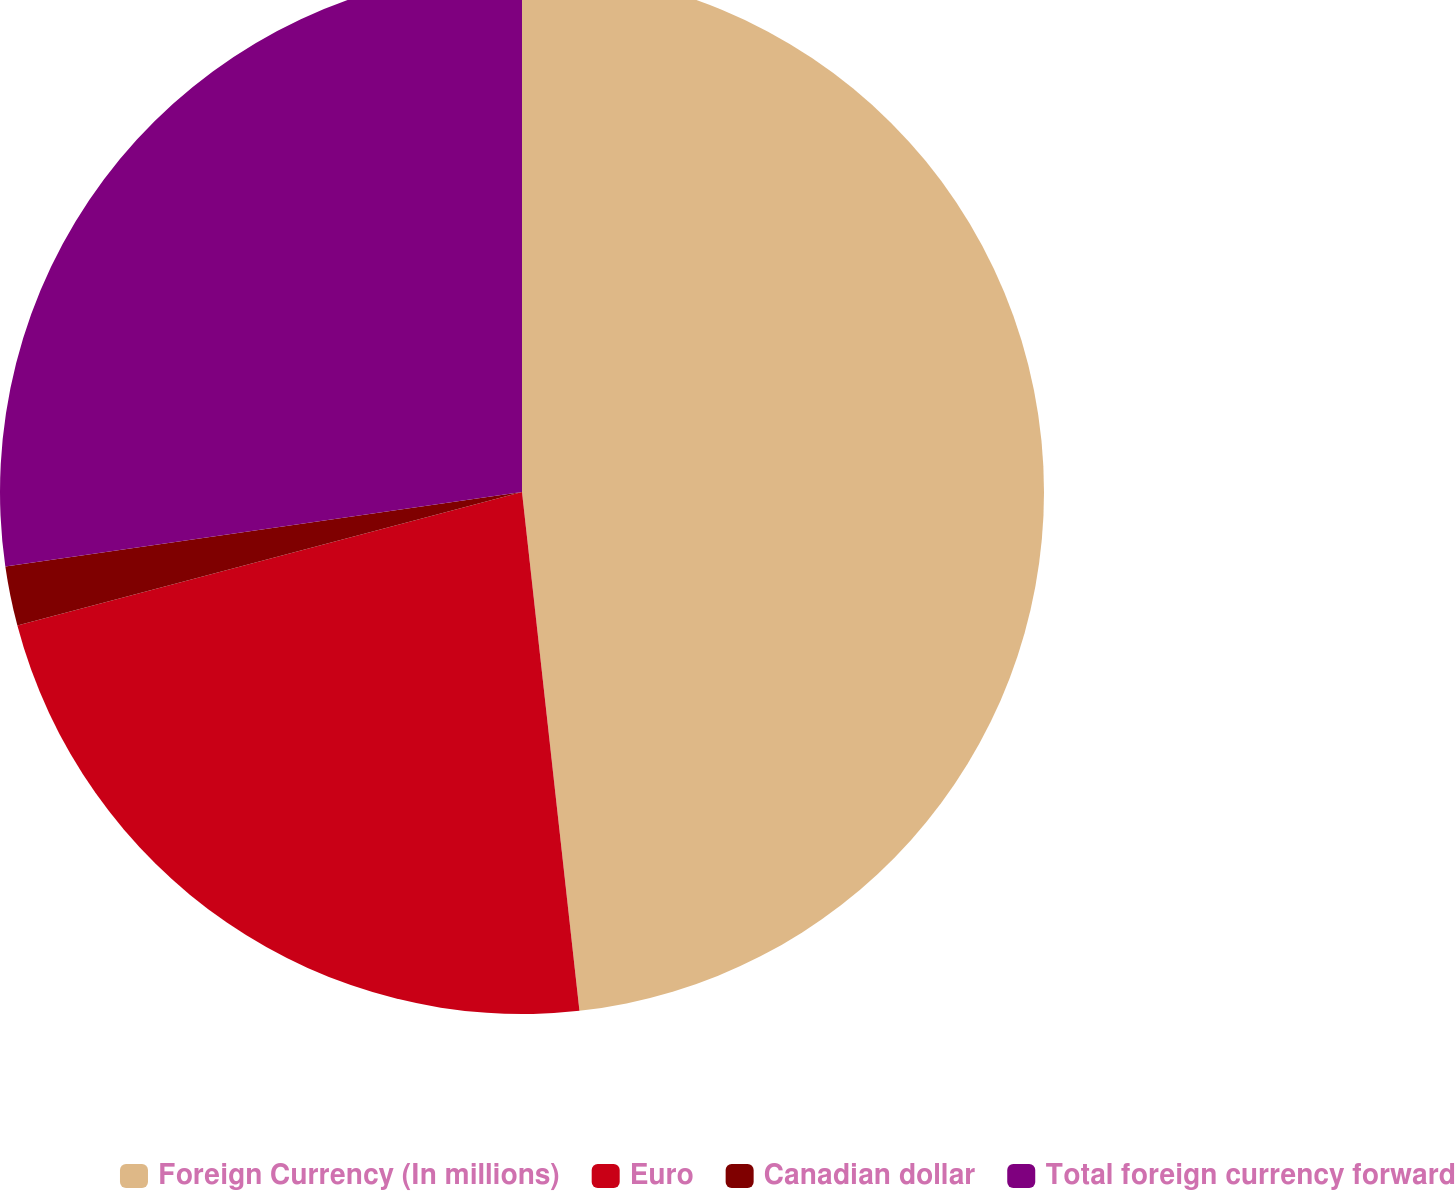Convert chart to OTSL. <chart><loc_0><loc_0><loc_500><loc_500><pie_chart><fcel>Foreign Currency (In millions)<fcel>Euro<fcel>Canadian dollar<fcel>Total foreign currency forward<nl><fcel>48.25%<fcel>22.64%<fcel>1.84%<fcel>27.28%<nl></chart> 